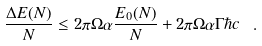<formula> <loc_0><loc_0><loc_500><loc_500>\frac { \Delta E ( N ) } { N } \leq 2 \pi \Omega \alpha \frac { E _ { 0 } ( N ) } { N } + 2 \pi \Omega \alpha \Gamma \hbar { c } \ .</formula> 